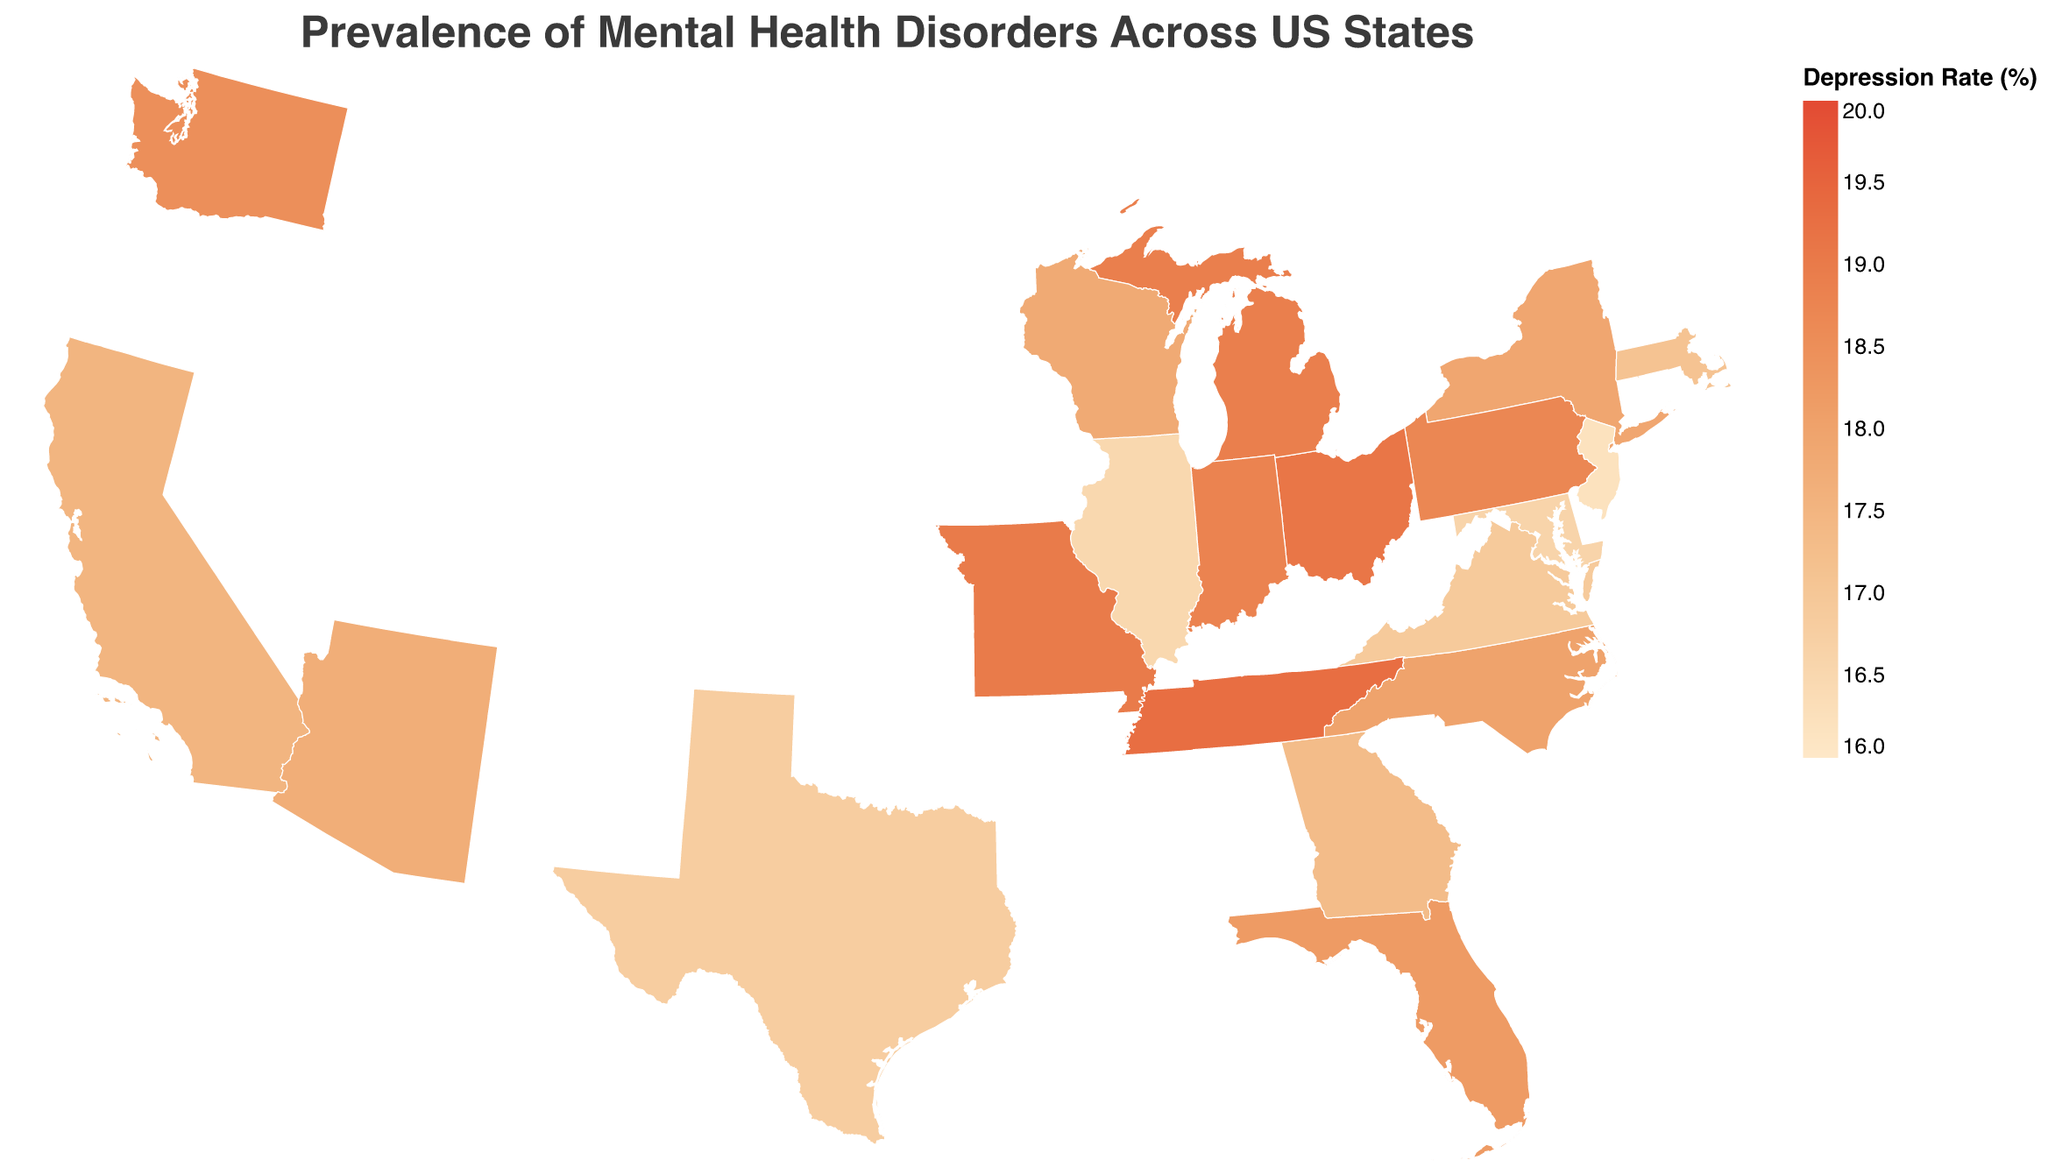What is the title of the figure? The title is usually located at the top of the figure, describing the main topic. In this case, it states "Prevalence of Mental Health Disorders Across US States".
Answer: Prevalence of Mental Health Disorders Across US States Which state has the highest depression rate? Observing the color intensity corresponding to the "Depression Rate (%)" in the legend, the state with the darkest shade (most intense color) has the highest rate. Ohio has the darkest shade.
Answer: Ohio What is the depression rate in Virginia? The tooltip for Virginia provides depression rate information. Hover over Virginia to see the tooltip, which includes "Depression Rate (%): 16.9".
Answer: 16.9% What are the anxiety and bipolar rates in Florida? The tooltip for Florida will display these rates. Hover over Florida to get "Anxiety Rate (%): 20.1" and "Bipolar Rate (%): 3.0".
Answer: Anxiety: 20.1%, Bipolar: 3.0% Which states have a depression rate higher than 19%? Looking at the legend and the color scale, states with the darkest shades have a depression rate higher than 19%. Tennessee, Ohio, and Missouri fit this criterion.
Answer: Tennessee, Ohio, Missouri What is the average depression rate among New York, Pennsylvania, and Michigan? To find the average, sum the depression rates of these states and divide by 3. For New York (17.9), Pennsylvania (18.7), and Michigan (18.9): (17.9 + 18.7 + 18.9) / 3 = 18.5.
Answer: 18.5% Is the depression rate in California higher or lower than the median depression rate of all states? List all depression rates, find the median (middle value in the sorted list). The rates are: 16.2, 16.5, 16.6, 16.8, 16.9, 17.1, 17.3, 17.5, 17.7, 17.8, 17.9, 18.0, 18.2, 18.5, 18.7, 18.8, 18.9, 19.0, 19.1, 19.3. Median is the average of the 10th and 11th values (17.8 + 17.9) / 2 = 17.85. Since California's rate is 17.5, it is lower than the median.
Answer: Lower Which state has the lowest anxiety rate, and what is that rate? The tooltip reveals individual state data. By checking the tooltips, New Jersey has the lowest anxiety rate at 18.0%.
Answer: New Jersey, 18.0% How does the anxiety rate in Washington compare to the average anxiety rate across all states? Calculate the average anxiety rate: (19.2 + 18.7 + 20.1 + 19.8 + 18.3 + 20.5 + ... + 20.9 + 18.4 + 19.6) / 20. Total sum is 391.4, average = 391.4 / 20 = 19.57. Washington's rate is 20.4, which is higher.
Answer: Higher What does the range of colors in the legend represent? The color range in the legend shows different levels of depression rates, with light colors representing lower rates and dark colors representing higher rates.
Answer: Depression Rate (%) 